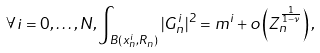Convert formula to latex. <formula><loc_0><loc_0><loc_500><loc_500>\forall i = 0 , \dots , N , \int _ { B ( x _ { n } ^ { i } , R _ { n } ) } | G _ { n } ^ { i } | ^ { 2 } = m ^ { i } + o \left ( Z _ { n } ^ { \frac { 1 } { 1 - \nu } } \right ) ,</formula> 